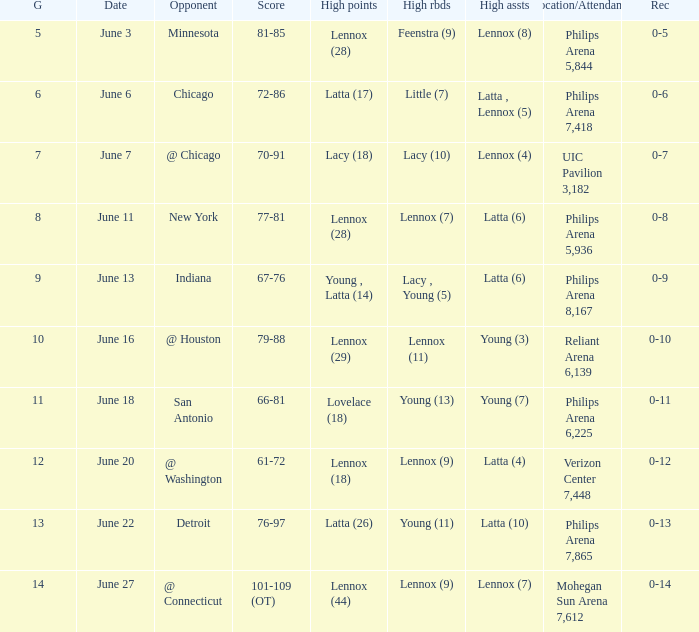Who made the highest assist in the game that scored 79-88? Young (3). 